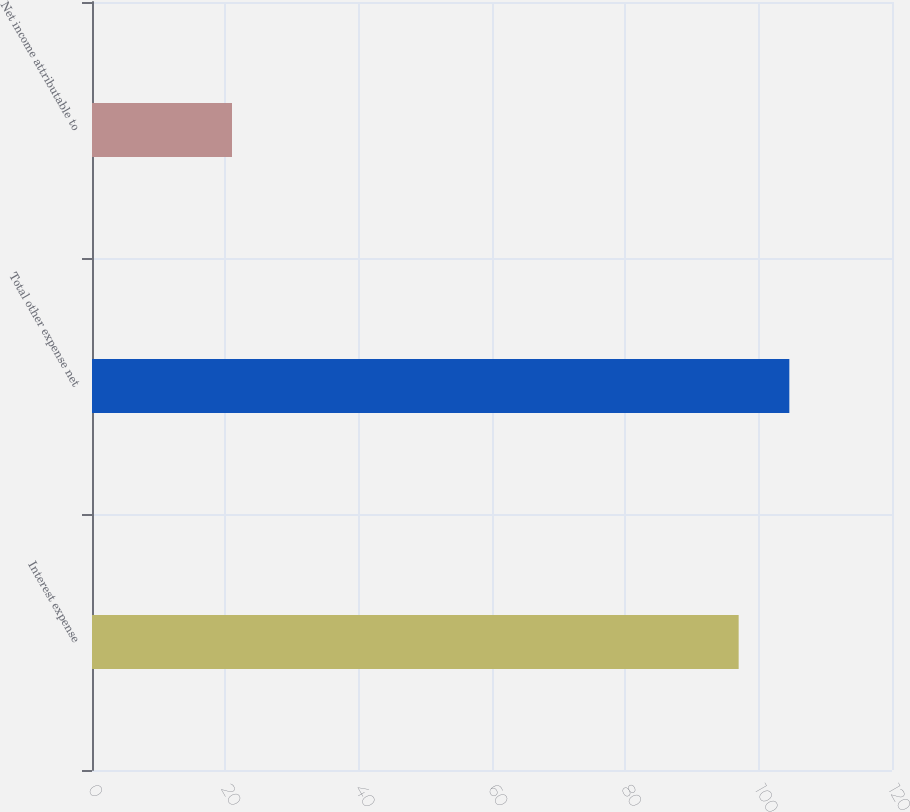<chart> <loc_0><loc_0><loc_500><loc_500><bar_chart><fcel>Interest expense<fcel>Total other expense net<fcel>Net income attributable to<nl><fcel>97<fcel>104.6<fcel>21<nl></chart> 